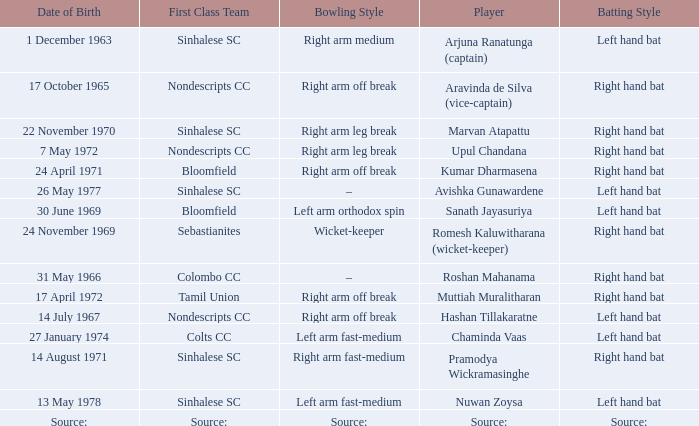When was roshan mahanama born? 31 May 1966. I'm looking to parse the entire table for insights. Could you assist me with that? {'header': ['Date of Birth', 'First Class Team', 'Bowling Style', 'Player', 'Batting Style'], 'rows': [['1 December 1963', 'Sinhalese SC', 'Right arm medium', 'Arjuna Ranatunga (captain)', 'Left hand bat'], ['17 October 1965', 'Nondescripts CC', 'Right arm off break', 'Aravinda de Silva (vice-captain)', 'Right hand bat'], ['22 November 1970', 'Sinhalese SC', 'Right arm leg break', 'Marvan Atapattu', 'Right hand bat'], ['7 May 1972', 'Nondescripts CC', 'Right arm leg break', 'Upul Chandana', 'Right hand bat'], ['24 April 1971', 'Bloomfield', 'Right arm off break', 'Kumar Dharmasena', 'Right hand bat'], ['26 May 1977', 'Sinhalese SC', '–', 'Avishka Gunawardene', 'Left hand bat'], ['30 June 1969', 'Bloomfield', 'Left arm orthodox spin', 'Sanath Jayasuriya', 'Left hand bat'], ['24 November 1969', 'Sebastianites', 'Wicket-keeper', 'Romesh Kaluwitharana (wicket-keeper)', 'Right hand bat'], ['31 May 1966', 'Colombo CC', '–', 'Roshan Mahanama', 'Right hand bat'], ['17 April 1972', 'Tamil Union', 'Right arm off break', 'Muttiah Muralitharan', 'Right hand bat'], ['14 July 1967', 'Nondescripts CC', 'Right arm off break', 'Hashan Tillakaratne', 'Left hand bat'], ['27 January 1974', 'Colts CC', 'Left arm fast-medium', 'Chaminda Vaas', 'Left hand bat'], ['14 August 1971', 'Sinhalese SC', 'Right arm fast-medium', 'Pramodya Wickramasinghe', 'Right hand bat'], ['13 May 1978', 'Sinhalese SC', 'Left arm fast-medium', 'Nuwan Zoysa', 'Left hand bat'], ['Source:', 'Source:', 'Source:', 'Source:', 'Source:']]} 